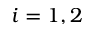<formula> <loc_0><loc_0><loc_500><loc_500>i = 1 , 2</formula> 